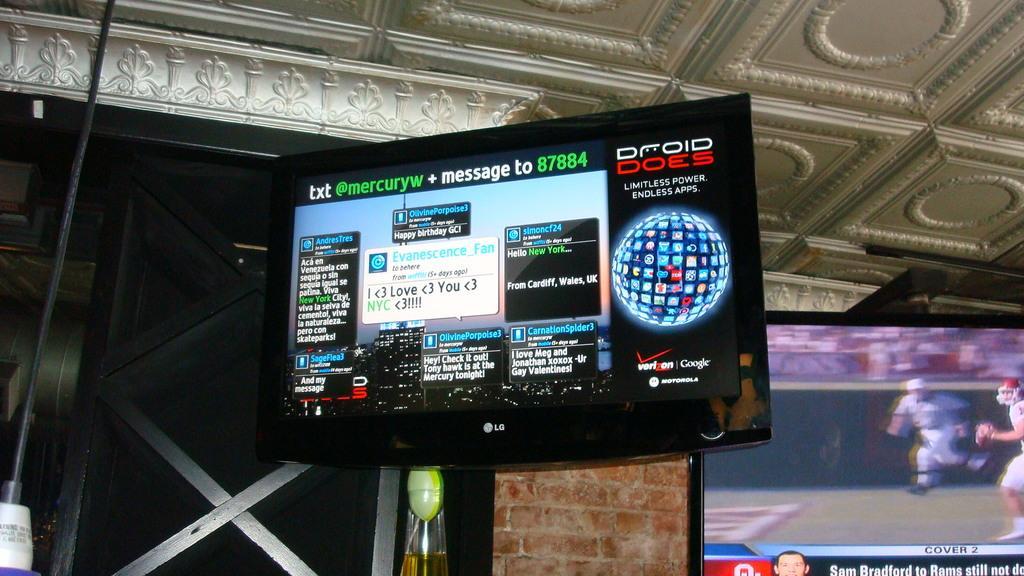How would you summarize this image in a sentence or two? In this image there is a screen attached to the wall. Right side there is a screen. There are people running on the grassland and some text are displayed on the screen. Background there is a wall. Bottom of the image there is a glass and an object are visible. Top of the image there is a roof. 